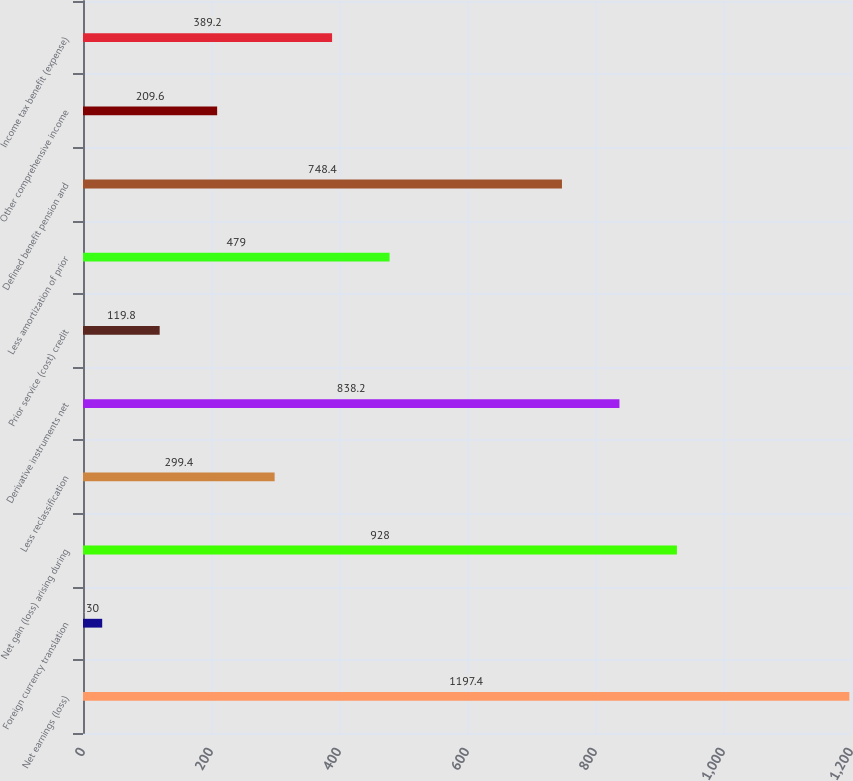Convert chart. <chart><loc_0><loc_0><loc_500><loc_500><bar_chart><fcel>Net earnings (loss)<fcel>Foreign currency translation<fcel>Net gain (loss) arising during<fcel>Less reclassification<fcel>Derivative instruments net<fcel>Prior service (cost) credit<fcel>Less amortization of prior<fcel>Defined benefit pension and<fcel>Other comprehensive income<fcel>Income tax benefit (expense)<nl><fcel>1197.4<fcel>30<fcel>928<fcel>299.4<fcel>838.2<fcel>119.8<fcel>479<fcel>748.4<fcel>209.6<fcel>389.2<nl></chart> 